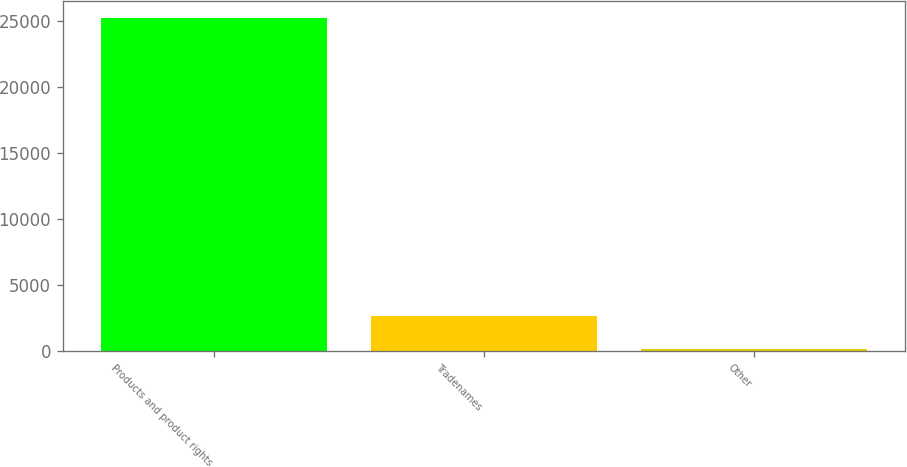Convert chart to OTSL. <chart><loc_0><loc_0><loc_500><loc_500><bar_chart><fcel>Products and product rights<fcel>Tradenames<fcel>Other<nl><fcel>25254<fcel>2661.3<fcel>151<nl></chart> 